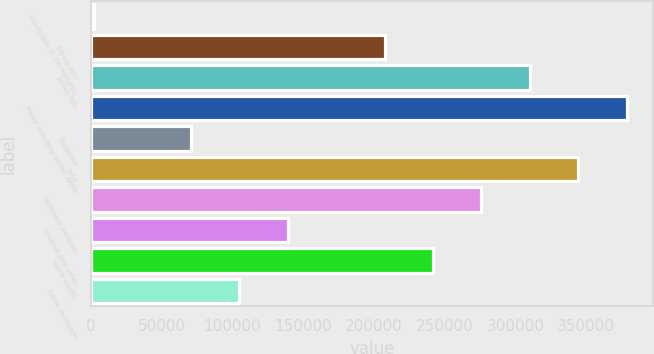<chart> <loc_0><loc_0><loc_500><loc_500><bar_chart><fcel>December 31 (in millions)<fcel>Senior lien<fcel>Junior lien<fcel>Prime including option ARMs<fcel>Subprime<fcel>Auto<fcel>Business banking<fcel>Student and other<fcel>Home equity<fcel>Prime mortgage<nl><fcel>2015<fcel>207419<fcel>310121<fcel>378589<fcel>70483<fcel>344355<fcel>275887<fcel>138951<fcel>241653<fcel>104717<nl></chart> 